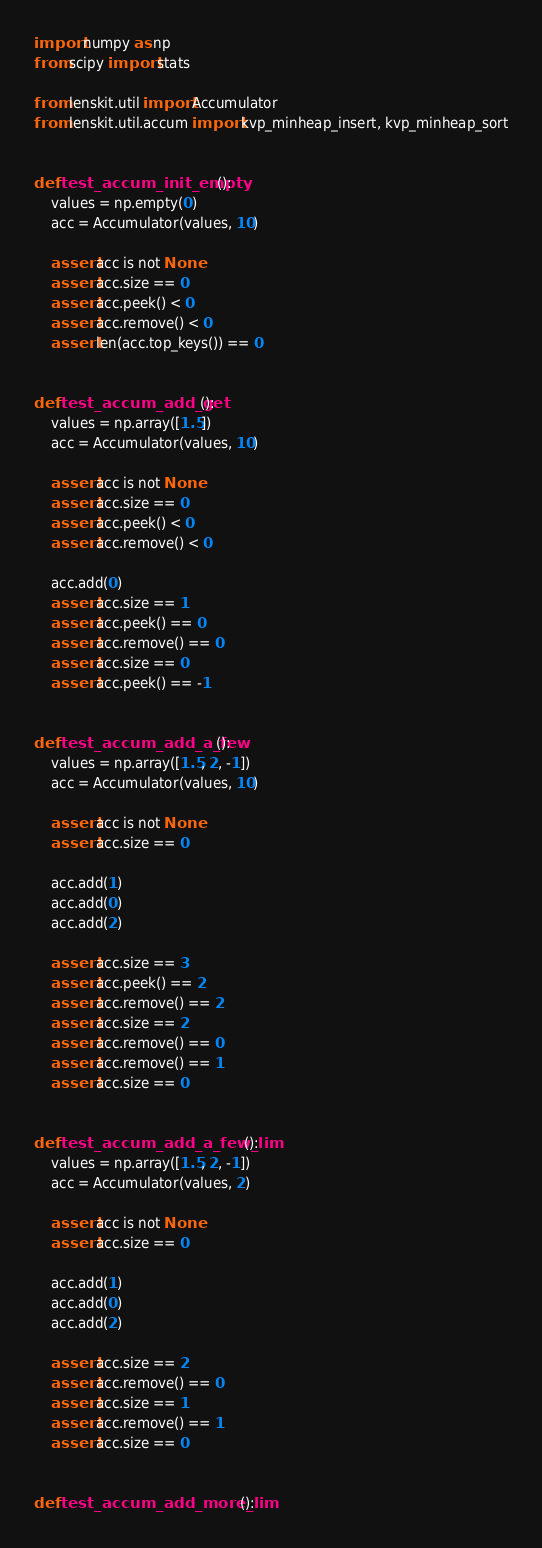<code> <loc_0><loc_0><loc_500><loc_500><_Python_>import numpy as np
from scipy import stats

from lenskit.util import Accumulator
from lenskit.util.accum import kvp_minheap_insert, kvp_minheap_sort


def test_accum_init_empty():
    values = np.empty(0)
    acc = Accumulator(values, 10)

    assert acc is not None
    assert acc.size == 0
    assert acc.peek() < 0
    assert acc.remove() < 0
    assert len(acc.top_keys()) == 0


def test_accum_add_get():
    values = np.array([1.5])
    acc = Accumulator(values, 10)

    assert acc is not None
    assert acc.size == 0
    assert acc.peek() < 0
    assert acc.remove() < 0

    acc.add(0)
    assert acc.size == 1
    assert acc.peek() == 0
    assert acc.remove() == 0
    assert acc.size == 0
    assert acc.peek() == -1


def test_accum_add_a_few():
    values = np.array([1.5, 2, -1])
    acc = Accumulator(values, 10)

    assert acc is not None
    assert acc.size == 0

    acc.add(1)
    acc.add(0)
    acc.add(2)

    assert acc.size == 3
    assert acc.peek() == 2
    assert acc.remove() == 2
    assert acc.size == 2
    assert acc.remove() == 0
    assert acc.remove() == 1
    assert acc.size == 0


def test_accum_add_a_few_lim():
    values = np.array([1.5, 2, -1])
    acc = Accumulator(values, 2)

    assert acc is not None
    assert acc.size == 0

    acc.add(1)
    acc.add(0)
    acc.add(2)

    assert acc.size == 2
    assert acc.remove() == 0
    assert acc.size == 1
    assert acc.remove() == 1
    assert acc.size == 0


def test_accum_add_more_lim():</code> 